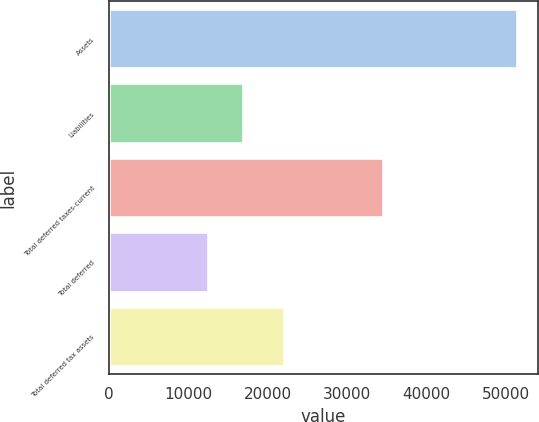Convert chart. <chart><loc_0><loc_0><loc_500><loc_500><bar_chart><fcel>Assets<fcel>Liabilities<fcel>Total deferred taxes-current<fcel>Total deferred<fcel>Total deferred tax assets<nl><fcel>51460<fcel>16938<fcel>34522<fcel>12439<fcel>22083<nl></chart> 